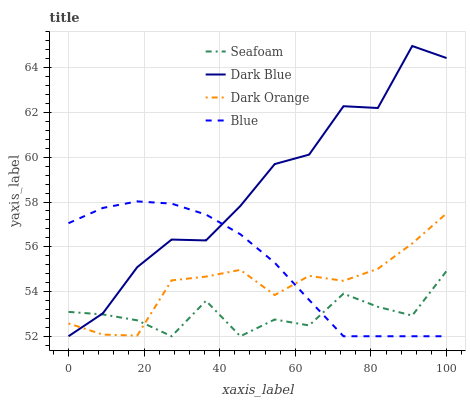Does Seafoam have the minimum area under the curve?
Answer yes or no. Yes. Does Dark Blue have the maximum area under the curve?
Answer yes or no. Yes. Does Dark Blue have the minimum area under the curve?
Answer yes or no. No. Does Seafoam have the maximum area under the curve?
Answer yes or no. No. Is Blue the smoothest?
Answer yes or no. Yes. Is Dark Blue the roughest?
Answer yes or no. Yes. Is Seafoam the smoothest?
Answer yes or no. No. Is Seafoam the roughest?
Answer yes or no. No. Does Blue have the lowest value?
Answer yes or no. Yes. Does Dark Orange have the lowest value?
Answer yes or no. No. Does Dark Blue have the highest value?
Answer yes or no. Yes. Does Seafoam have the highest value?
Answer yes or no. No. Does Dark Orange intersect Dark Blue?
Answer yes or no. Yes. Is Dark Orange less than Dark Blue?
Answer yes or no. No. Is Dark Orange greater than Dark Blue?
Answer yes or no. No. 